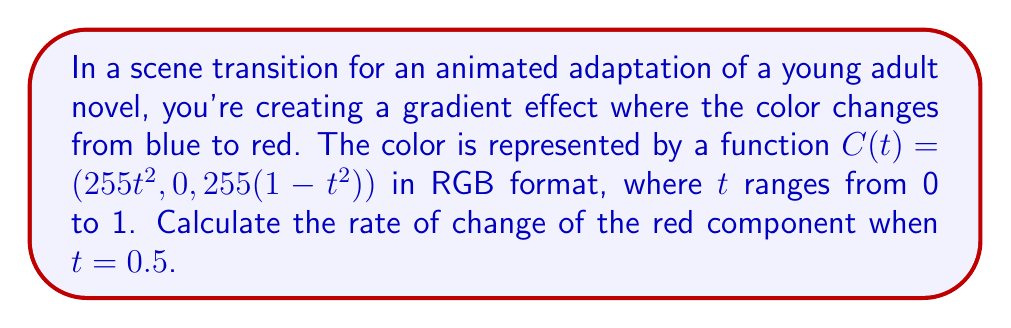Could you help me with this problem? To solve this problem, we need to follow these steps:

1) The color function $C(t)$ is given as $(255t^2, 0, 255(1-t^2))$ in RGB format.

2) We're interested in the red component, which is $255t^2$.

3) To find the rate of change, we need to differentiate this function with respect to $t$:

   $$\frac{d}{dt}(255t^2) = 255 \cdot 2t = 510t$$

4) This derivative represents the instantaneous rate of change of the red component at any time $t$.

5) We're asked to find the rate of change when $t = 0.5$, so we substitute this value:

   $$510 \cdot 0.5 = 255$$

Therefore, when $t = 0.5$, the red component is changing at a rate of 255 units per unit change in $t$.
Answer: 255 